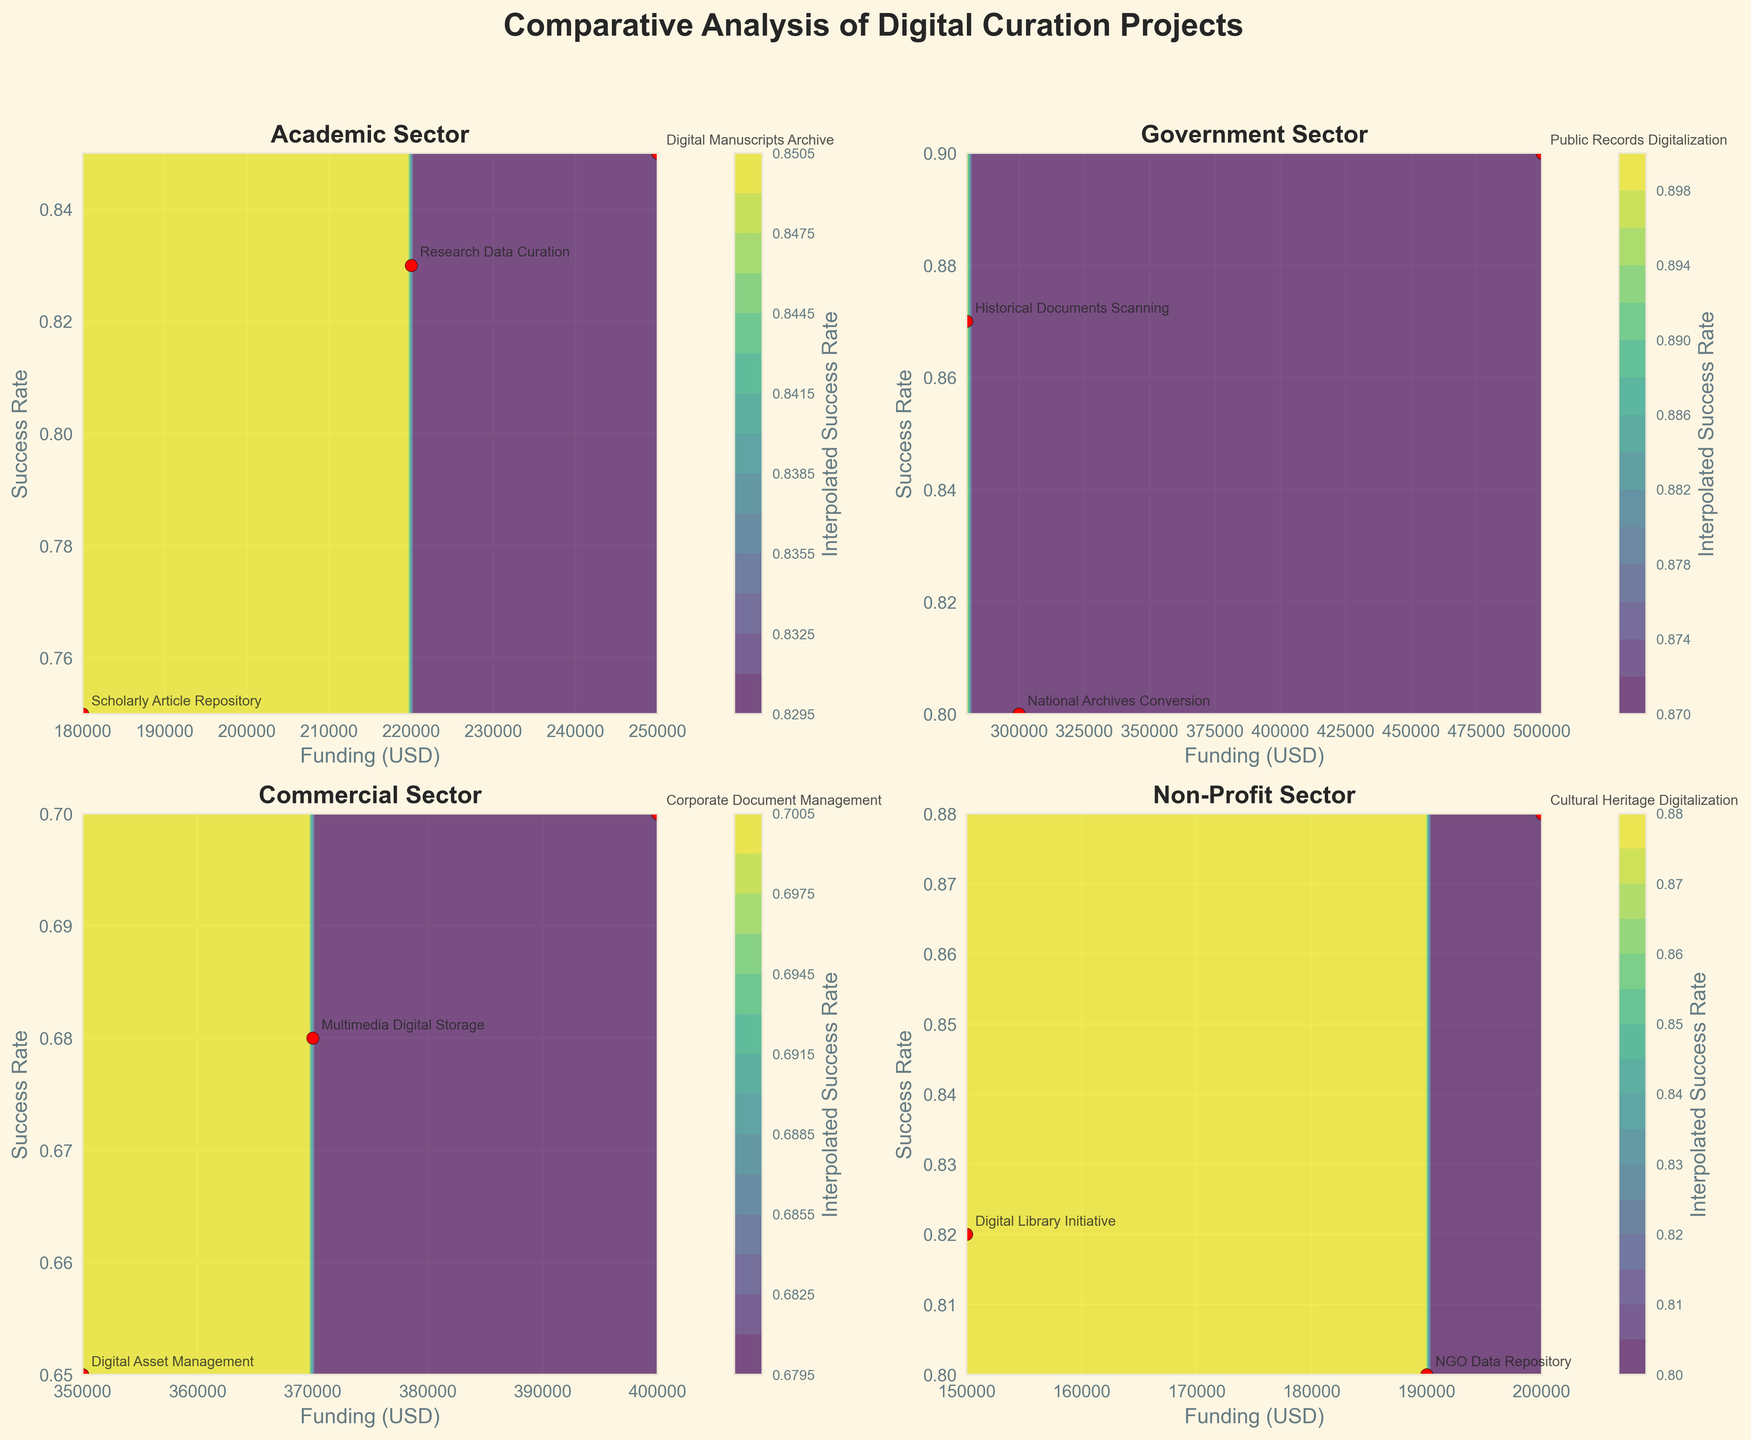What is the title of the figure? The title is typically the most prominent text located at the top of the figure. It provides a summary of what the figure represents. By looking at the top of the figure, the title reads "Comparative Analysis of Digital Curation Projects".
Answer: Comparative Analysis of Digital Curation Projects How many data points are plotted in the Academic sector subplot? To determine this, look specifically at the Academic sector subplot and count the red scatter points (representing data points) within that subplot. Counting the red points in the Academic sector, there are 3 projects plotted.
Answer: 3 Which sector has the highest success rate for a project, and what is that rate? To find the highest success rate, examine the success rate values on the vertical axis of each subplot. Identify the highest data point across all sectors. In the Government sector subplot, the project "Public Records Digitalization" has a success rate of 0.90, which is the highest observed rate.
Answer: Government, 0.90 Which sector shows the broadest range of funding? Observe the horizontal axis labeled "Funding (USD)" in each subplot and note the range of funding amounts depicted. The Government sector shows funding amounts ranging from 280000 to 500000 USD, indicating the broadest range compared to other sectors.
Answer: Government How does the success rate of the "Corporate Document Management" project compare to the "Digital Asset Management" project in the Commercial sector? In the Commercial sector subplot, locate the projects "Corporate Document Management" and "Digital Asset Management" and compare their positions on the vertical success rate axis. "Corporate Document Management" has a success rate of 0.70, while "Digital Asset Management" has a success rate of 0.65. Therefore, "Corporate Document Management" has a higher success rate.
Answer: Corporate Document Management is higher What is the success rate and funding amount of the "Digital Library Initiative" project in the Non-Profit sector? Focus on the subplot for the Non-Profit sector and locate the "Digital Library Initiative" project. Identify the values along the horizontal and vertical axes where the project is plotted. The "Digital Library Initiative" project has a success rate of 0.82 and a funding amount of 150000 USD.
Answer: 0.82, 150000 USD Which sector has the lowest success rate in any of its projects, and what is that rate? Examine the success rate values on the vertical axis of each subplot and find the lowest data point across all sectors. In the Commercial sector subplot, the project "Digital Asset Management" has the lowest success rate of 0.65.
Answer: Commercial, 0.65 What is the average success rate of Non-Profit sector projects? Calculate the average success rate of all Non-Profit sector projects by adding their success rates and dividing by the number of projects. The success rates are 0.88, 0.82, and 0.80. Sum = 0.88 + 0.82 + 0.80 = 2.50, and dividing by 3, the average is 2.50 / 3 = 0.83.
Answer: 0.83 What appears to be the relationship between funding and success rate in the Government sector? Examine the Government sector subplot, noting the scatter plot trend. Most projects are clustered at higher success rates and funding levels, suggesting a positive correlation where higher funding is associated with higher success rates.
Answer: Positive correlation 